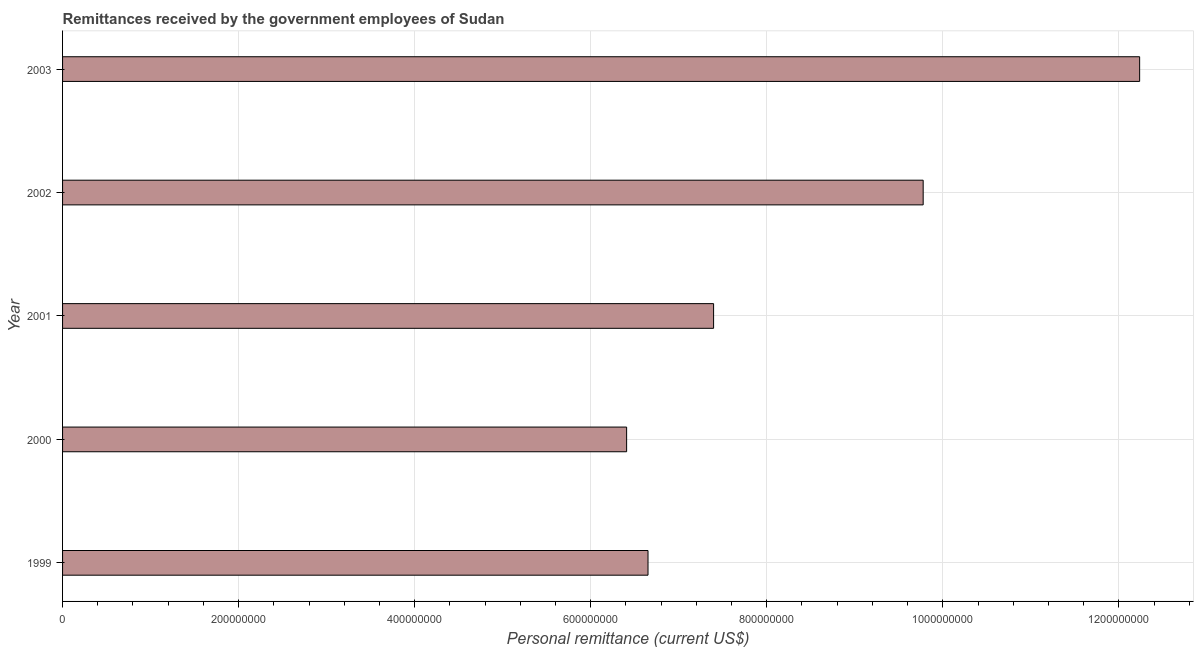Does the graph contain grids?
Ensure brevity in your answer.  Yes. What is the title of the graph?
Keep it short and to the point. Remittances received by the government employees of Sudan. What is the label or title of the X-axis?
Ensure brevity in your answer.  Personal remittance (current US$). What is the label or title of the Y-axis?
Keep it short and to the point. Year. What is the personal remittances in 2000?
Ensure brevity in your answer.  6.41e+08. Across all years, what is the maximum personal remittances?
Your response must be concise. 1.22e+09. Across all years, what is the minimum personal remittances?
Keep it short and to the point. 6.41e+08. In which year was the personal remittances minimum?
Offer a very short reply. 2000. What is the sum of the personal remittances?
Ensure brevity in your answer.  4.25e+09. What is the difference between the personal remittances in 2000 and 2002?
Provide a succinct answer. -3.37e+08. What is the average personal remittances per year?
Keep it short and to the point. 8.49e+08. What is the median personal remittances?
Offer a very short reply. 7.40e+08. What is the ratio of the personal remittances in 1999 to that in 2000?
Ensure brevity in your answer.  1.04. What is the difference between the highest and the second highest personal remittances?
Ensure brevity in your answer.  2.46e+08. What is the difference between the highest and the lowest personal remittances?
Offer a terse response. 5.83e+08. In how many years, is the personal remittances greater than the average personal remittances taken over all years?
Provide a short and direct response. 2. How many years are there in the graph?
Provide a short and direct response. 5. What is the difference between two consecutive major ticks on the X-axis?
Ensure brevity in your answer.  2.00e+08. What is the Personal remittance (current US$) of 1999?
Give a very brief answer. 6.65e+08. What is the Personal remittance (current US$) in 2000?
Offer a terse response. 6.41e+08. What is the Personal remittance (current US$) in 2001?
Provide a short and direct response. 7.40e+08. What is the Personal remittance (current US$) of 2002?
Keep it short and to the point. 9.78e+08. What is the Personal remittance (current US$) in 2003?
Offer a very short reply. 1.22e+09. What is the difference between the Personal remittance (current US$) in 1999 and 2000?
Ensure brevity in your answer.  2.43e+07. What is the difference between the Personal remittance (current US$) in 1999 and 2001?
Your answer should be compact. -7.45e+07. What is the difference between the Personal remittance (current US$) in 1999 and 2002?
Your answer should be compact. -3.13e+08. What is the difference between the Personal remittance (current US$) in 1999 and 2003?
Offer a terse response. -5.59e+08. What is the difference between the Personal remittance (current US$) in 2000 and 2001?
Offer a terse response. -9.88e+07. What is the difference between the Personal remittance (current US$) in 2000 and 2002?
Ensure brevity in your answer.  -3.37e+08. What is the difference between the Personal remittance (current US$) in 2000 and 2003?
Ensure brevity in your answer.  -5.83e+08. What is the difference between the Personal remittance (current US$) in 2001 and 2002?
Your answer should be very brief. -2.38e+08. What is the difference between the Personal remittance (current US$) in 2001 and 2003?
Your answer should be very brief. -4.84e+08. What is the difference between the Personal remittance (current US$) in 2002 and 2003?
Offer a terse response. -2.46e+08. What is the ratio of the Personal remittance (current US$) in 1999 to that in 2000?
Give a very brief answer. 1.04. What is the ratio of the Personal remittance (current US$) in 1999 to that in 2001?
Give a very brief answer. 0.9. What is the ratio of the Personal remittance (current US$) in 1999 to that in 2002?
Your answer should be compact. 0.68. What is the ratio of the Personal remittance (current US$) in 1999 to that in 2003?
Your answer should be compact. 0.54. What is the ratio of the Personal remittance (current US$) in 2000 to that in 2001?
Your response must be concise. 0.87. What is the ratio of the Personal remittance (current US$) in 2000 to that in 2002?
Your answer should be very brief. 0.66. What is the ratio of the Personal remittance (current US$) in 2000 to that in 2003?
Your answer should be compact. 0.52. What is the ratio of the Personal remittance (current US$) in 2001 to that in 2002?
Ensure brevity in your answer.  0.76. What is the ratio of the Personal remittance (current US$) in 2001 to that in 2003?
Provide a short and direct response. 0.6. What is the ratio of the Personal remittance (current US$) in 2002 to that in 2003?
Keep it short and to the point. 0.8. 